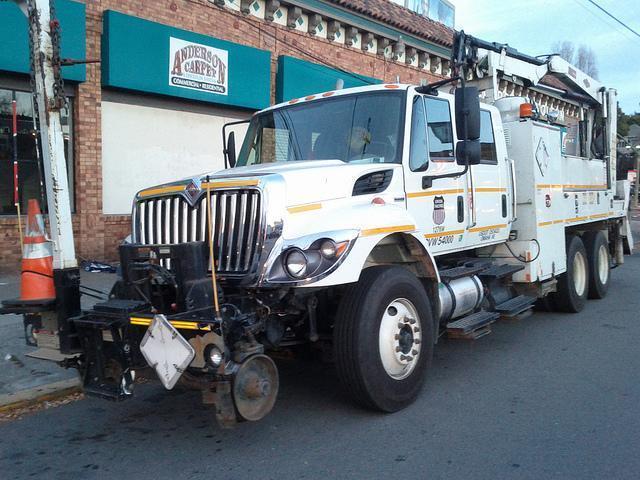How many wheels does the truck have?
Give a very brief answer. 10. How many people are in the truck lift?
Give a very brief answer. 1. How many trucks are there?
Give a very brief answer. 1. 